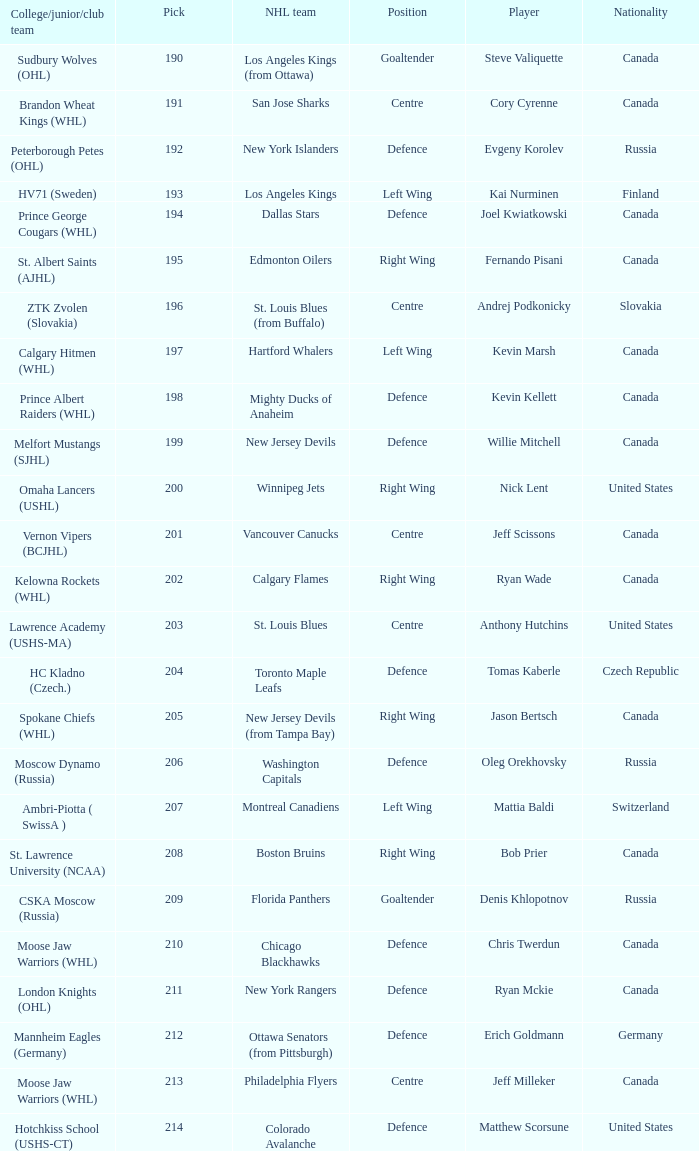Can you parse all the data within this table? {'header': ['College/junior/club team', 'Pick', 'NHL team', 'Position', 'Player', 'Nationality'], 'rows': [['Sudbury Wolves (OHL)', '190', 'Los Angeles Kings (from Ottawa)', 'Goaltender', 'Steve Valiquette', 'Canada'], ['Brandon Wheat Kings (WHL)', '191', 'San Jose Sharks', 'Centre', 'Cory Cyrenne', 'Canada'], ['Peterborough Petes (OHL)', '192', 'New York Islanders', 'Defence', 'Evgeny Korolev', 'Russia'], ['HV71 (Sweden)', '193', 'Los Angeles Kings', 'Left Wing', 'Kai Nurminen', 'Finland'], ['Prince George Cougars (WHL)', '194', 'Dallas Stars', 'Defence', 'Joel Kwiatkowski', 'Canada'], ['St. Albert Saints (AJHL)', '195', 'Edmonton Oilers', 'Right Wing', 'Fernando Pisani', 'Canada'], ['ZTK Zvolen (Slovakia)', '196', 'St. Louis Blues (from Buffalo)', 'Centre', 'Andrej Podkonicky', 'Slovakia'], ['Calgary Hitmen (WHL)', '197', 'Hartford Whalers', 'Left Wing', 'Kevin Marsh', 'Canada'], ['Prince Albert Raiders (WHL)', '198', 'Mighty Ducks of Anaheim', 'Defence', 'Kevin Kellett', 'Canada'], ['Melfort Mustangs (SJHL)', '199', 'New Jersey Devils', 'Defence', 'Willie Mitchell', 'Canada'], ['Omaha Lancers (USHL)', '200', 'Winnipeg Jets', 'Right Wing', 'Nick Lent', 'United States'], ['Vernon Vipers (BCJHL)', '201', 'Vancouver Canucks', 'Centre', 'Jeff Scissons', 'Canada'], ['Kelowna Rockets (WHL)', '202', 'Calgary Flames', 'Right Wing', 'Ryan Wade', 'Canada'], ['Lawrence Academy (USHS-MA)', '203', 'St. Louis Blues', 'Centre', 'Anthony Hutchins', 'United States'], ['HC Kladno (Czech.)', '204', 'Toronto Maple Leafs', 'Defence', 'Tomas Kaberle', 'Czech Republic'], ['Spokane Chiefs (WHL)', '205', 'New Jersey Devils (from Tampa Bay)', 'Right Wing', 'Jason Bertsch', 'Canada'], ['Moscow Dynamo (Russia)', '206', 'Washington Capitals', 'Defence', 'Oleg Orekhovsky', 'Russia'], ['Ambri-Piotta ( SwissA )', '207', 'Montreal Canadiens', 'Left Wing', 'Mattia Baldi', 'Switzerland'], ['St. Lawrence University (NCAA)', '208', 'Boston Bruins', 'Right Wing', 'Bob Prier', 'Canada'], ['CSKA Moscow (Russia)', '209', 'Florida Panthers', 'Goaltender', 'Denis Khlopotnov', 'Russia'], ['Moose Jaw Warriors (WHL)', '210', 'Chicago Blackhawks', 'Defence', 'Chris Twerdun', 'Canada'], ['London Knights (OHL)', '211', 'New York Rangers', 'Defence', 'Ryan Mckie', 'Canada'], ['Mannheim Eagles (Germany)', '212', 'Ottawa Senators (from Pittsburgh)', 'Defence', 'Erich Goldmann', 'Germany'], ['Moose Jaw Warriors (WHL)', '213', 'Philadelphia Flyers', 'Centre', 'Jeff Milleker', 'Canada'], ['Hotchkiss School (USHS-CT)', '214', 'Colorado Avalanche', 'Defence', 'Matthew Scorsune', 'United States']]} Name the most pick for evgeny korolev 192.0. 